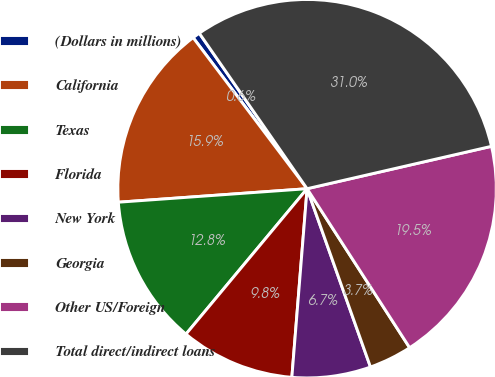<chart> <loc_0><loc_0><loc_500><loc_500><pie_chart><fcel>(Dollars in millions)<fcel>California<fcel>Texas<fcel>Florida<fcel>New York<fcel>Georgia<fcel>Other US/Foreign<fcel>Total direct/indirect loans<nl><fcel>0.64%<fcel>15.85%<fcel>12.81%<fcel>9.77%<fcel>6.72%<fcel>3.68%<fcel>19.48%<fcel>31.05%<nl></chart> 